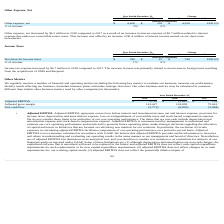According to Everbridge's financial document, What was the decrease in the Other expense, net in 2018? According to the financial document, $4.3 million. The relevant text states: "Other expense, net decreased by $4.3 million in 2018 compared to 2017 as a result of an increase in interest expense of $5.7 million related to i..." Also, What was the Other expense, net in 2018 and 2017 respectively? The document shows two values: 4,628 and 302 (in thousands). From the document: "Other expense, net $ 4,628 $ 302 $ 4,326 1432.5% Other expense, net $ 4,628 $ 302 $ 4,326 1432.5%..." Also, What is the % change for other expense, net between 2017 and 2018? According to the financial document, 1432.5 (percentage). The relevant text states: "Other expense, net $ 4,628 $ 302 $ 4,326 1432.5%..." Also, can you calculate: What is the average Other expense, net for 2017 and 2018? To answer this question, I need to perform calculations using the financial data. The calculation is: (4,628 + 302) / 2, which equals 2465 (in thousands). This is based on the information: "Other expense, net $ 4,628 $ 302 $ 4,326 1432.5% Other expense, net $ 4,628 $ 302 $ 4,326 1432.5%..." The key data points involved are: 302, 4,628. Additionally, In which year was Other expense, net less than 1,000 thousands? According to the financial document, 2017. The relevant text states: "2018 2017 $ %..." Also, can you calculate: What is the change in the % of revenue between 2017 and 2018? Based on the calculation: 3 - 0, the result is 3 (percentage). This is based on the information: "Other expense, net $ 4,628 $ 302 $ 4,326 1432.5% Other expense, net $ 4,628 $ 302 $ 4,326 1432.5%..." The key data points involved are: 0. 